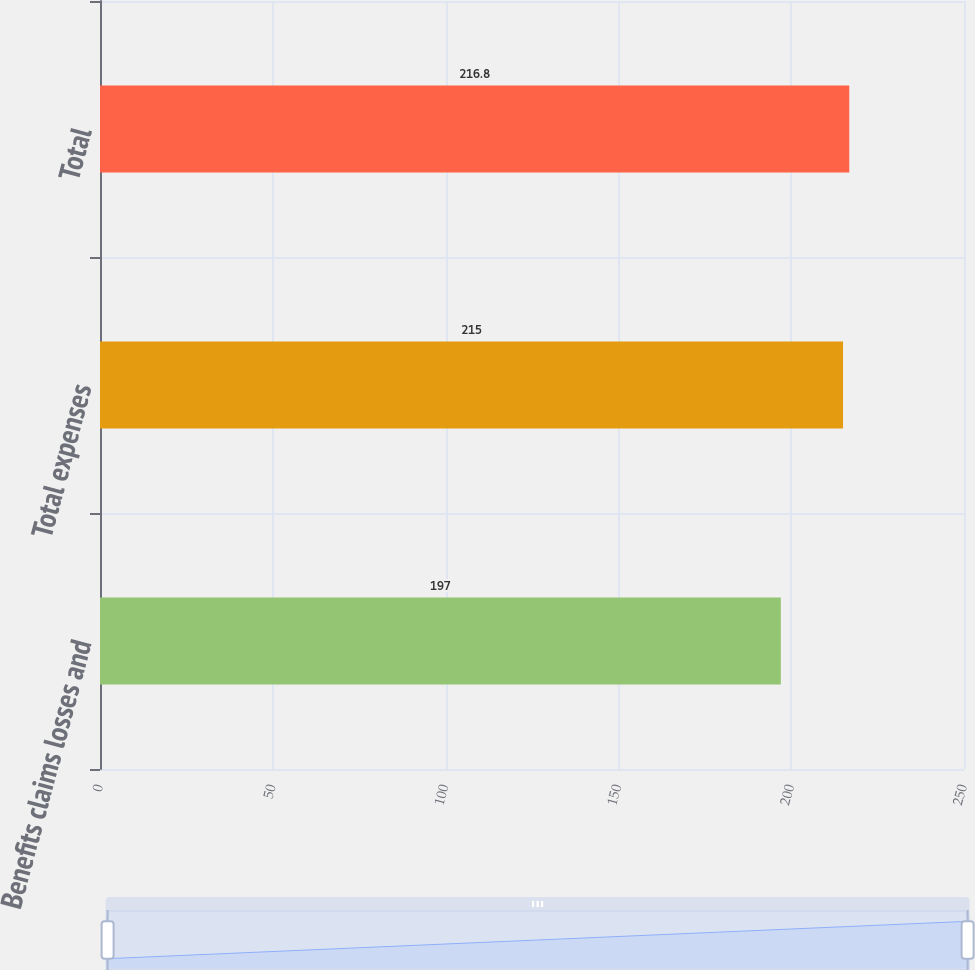Convert chart. <chart><loc_0><loc_0><loc_500><loc_500><bar_chart><fcel>Benefits claims losses and<fcel>Total expenses<fcel>Total<nl><fcel>197<fcel>215<fcel>216.8<nl></chart> 